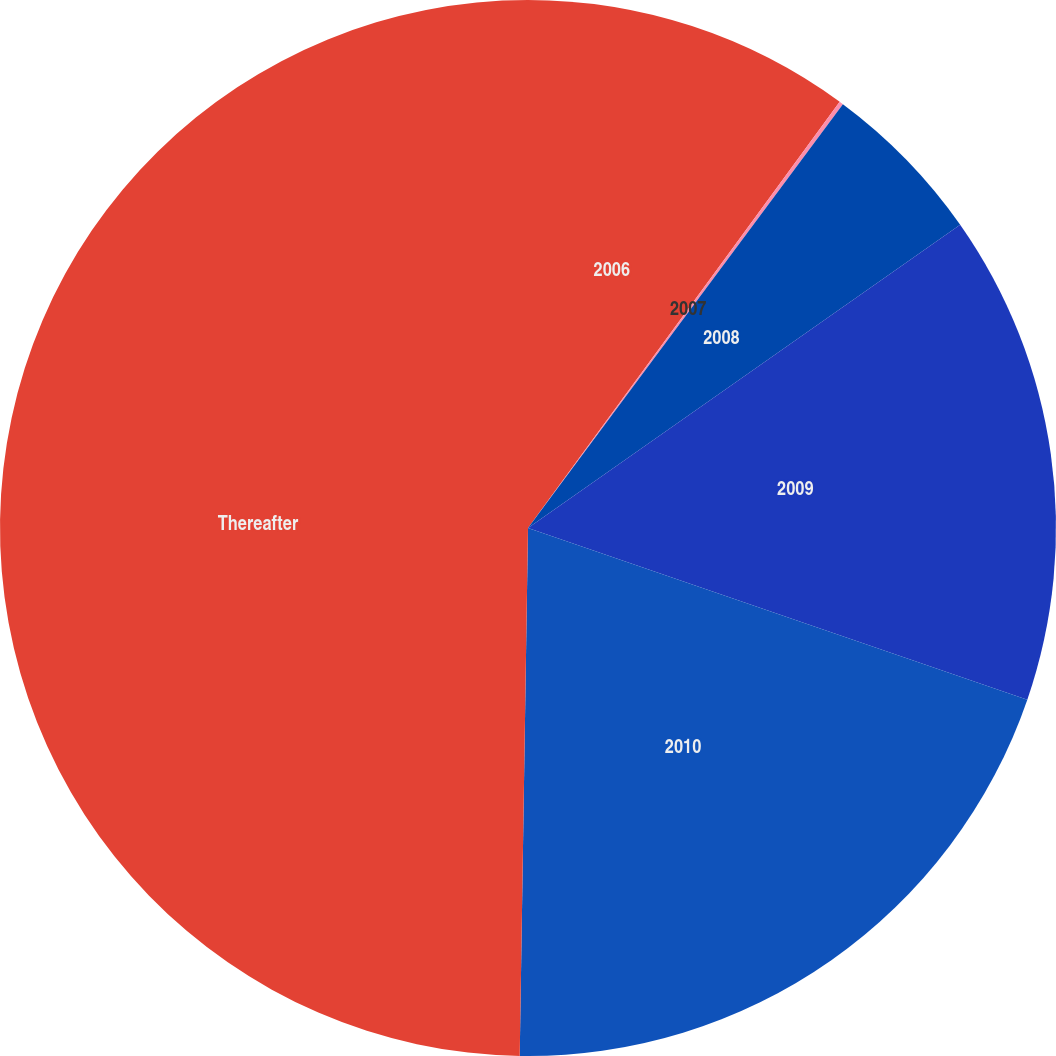<chart> <loc_0><loc_0><loc_500><loc_500><pie_chart><fcel>2006<fcel>2007<fcel>2008<fcel>2009<fcel>2010<fcel>Thereafter<nl><fcel>10.05%<fcel>0.12%<fcel>5.09%<fcel>15.01%<fcel>19.98%<fcel>49.75%<nl></chart> 